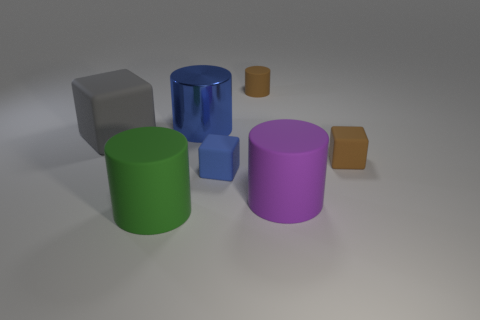There is a large blue shiny cylinder; what number of blue shiny cylinders are on the right side of it?
Ensure brevity in your answer.  0. What is the size of the rubber cylinder behind the brown thing that is in front of the small matte cylinder?
Keep it short and to the point. Small. Is the shape of the big matte object in front of the purple cylinder the same as the big rubber object that is to the left of the big green cylinder?
Provide a succinct answer. No. What is the shape of the rubber thing on the right side of the big matte thing that is to the right of the brown rubber cylinder?
Your answer should be very brief. Cube. What is the size of the matte thing that is behind the purple cylinder and in front of the brown block?
Provide a short and direct response. Small. There is a purple matte thing; does it have the same shape as the tiny blue thing that is behind the green rubber object?
Your answer should be very brief. No. There is a blue thing that is the same shape as the gray object; what size is it?
Give a very brief answer. Small. Do the shiny thing and the rubber cylinder that is left of the tiny brown cylinder have the same color?
Your answer should be very brief. No. What number of other objects are the same size as the green object?
Ensure brevity in your answer.  3. What shape is the large matte object that is to the right of the big matte object in front of the big matte thing that is right of the green object?
Keep it short and to the point. Cylinder. 